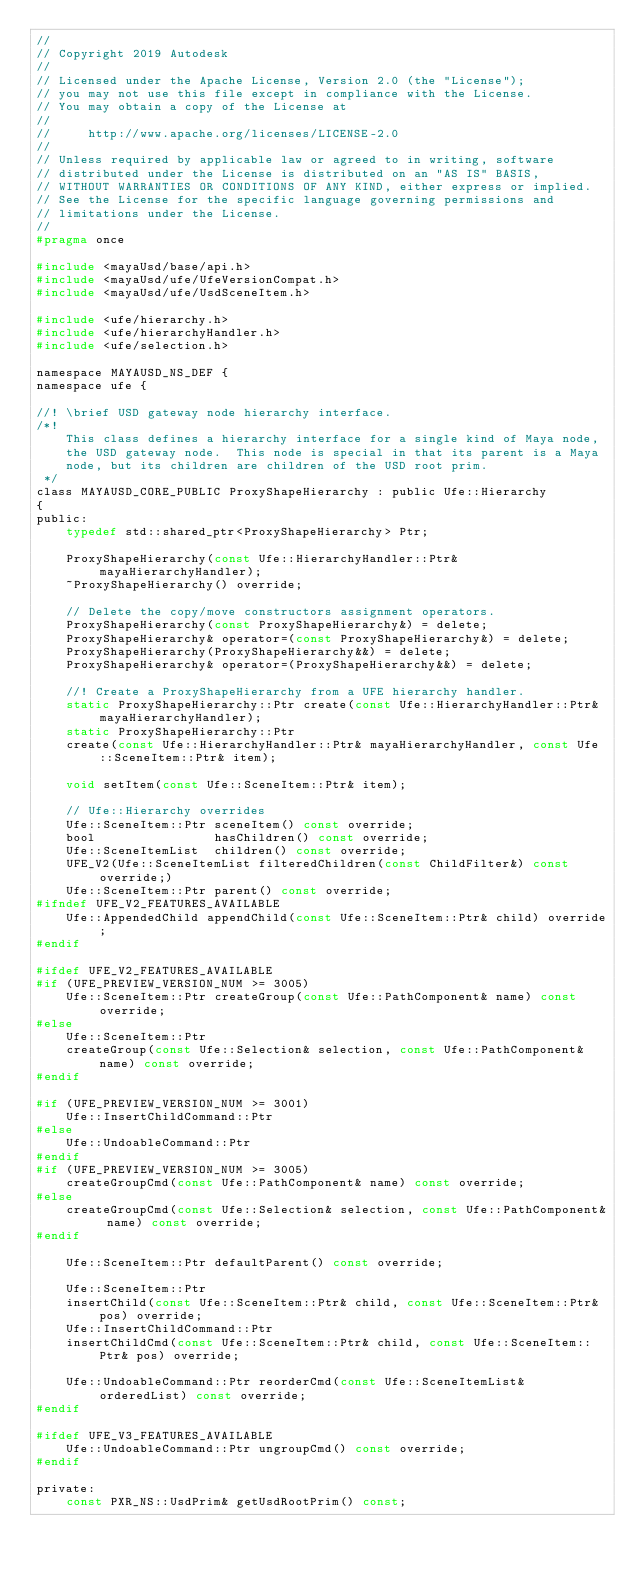<code> <loc_0><loc_0><loc_500><loc_500><_C_>//
// Copyright 2019 Autodesk
//
// Licensed under the Apache License, Version 2.0 (the "License");
// you may not use this file except in compliance with the License.
// You may obtain a copy of the License at
//
//     http://www.apache.org/licenses/LICENSE-2.0
//
// Unless required by applicable law or agreed to in writing, software
// distributed under the License is distributed on an "AS IS" BASIS,
// WITHOUT WARRANTIES OR CONDITIONS OF ANY KIND, either express or implied.
// See the License for the specific language governing permissions and
// limitations under the License.
//
#pragma once

#include <mayaUsd/base/api.h>
#include <mayaUsd/ufe/UfeVersionCompat.h>
#include <mayaUsd/ufe/UsdSceneItem.h>

#include <ufe/hierarchy.h>
#include <ufe/hierarchyHandler.h>
#include <ufe/selection.h>

namespace MAYAUSD_NS_DEF {
namespace ufe {

//! \brief USD gateway node hierarchy interface.
/*!
    This class defines a hierarchy interface for a single kind of Maya node,
    the USD gateway node.  This node is special in that its parent is a Maya
    node, but its children are children of the USD root prim.
 */
class MAYAUSD_CORE_PUBLIC ProxyShapeHierarchy : public Ufe::Hierarchy
{
public:
    typedef std::shared_ptr<ProxyShapeHierarchy> Ptr;

    ProxyShapeHierarchy(const Ufe::HierarchyHandler::Ptr& mayaHierarchyHandler);
    ~ProxyShapeHierarchy() override;

    // Delete the copy/move constructors assignment operators.
    ProxyShapeHierarchy(const ProxyShapeHierarchy&) = delete;
    ProxyShapeHierarchy& operator=(const ProxyShapeHierarchy&) = delete;
    ProxyShapeHierarchy(ProxyShapeHierarchy&&) = delete;
    ProxyShapeHierarchy& operator=(ProxyShapeHierarchy&&) = delete;

    //! Create a ProxyShapeHierarchy from a UFE hierarchy handler.
    static ProxyShapeHierarchy::Ptr create(const Ufe::HierarchyHandler::Ptr& mayaHierarchyHandler);
    static ProxyShapeHierarchy::Ptr
    create(const Ufe::HierarchyHandler::Ptr& mayaHierarchyHandler, const Ufe::SceneItem::Ptr& item);

    void setItem(const Ufe::SceneItem::Ptr& item);

    // Ufe::Hierarchy overrides
    Ufe::SceneItem::Ptr sceneItem() const override;
    bool                hasChildren() const override;
    Ufe::SceneItemList  children() const override;
    UFE_V2(Ufe::SceneItemList filteredChildren(const ChildFilter&) const override;)
    Ufe::SceneItem::Ptr parent() const override;
#ifndef UFE_V2_FEATURES_AVAILABLE
    Ufe::AppendedChild appendChild(const Ufe::SceneItem::Ptr& child) override;
#endif

#ifdef UFE_V2_FEATURES_AVAILABLE
#if (UFE_PREVIEW_VERSION_NUM >= 3005)
    Ufe::SceneItem::Ptr createGroup(const Ufe::PathComponent& name) const override;
#else
    Ufe::SceneItem::Ptr
    createGroup(const Ufe::Selection& selection, const Ufe::PathComponent& name) const override;
#endif

#if (UFE_PREVIEW_VERSION_NUM >= 3001)
    Ufe::InsertChildCommand::Ptr
#else
    Ufe::UndoableCommand::Ptr
#endif
#if (UFE_PREVIEW_VERSION_NUM >= 3005)
    createGroupCmd(const Ufe::PathComponent& name) const override;
#else
    createGroupCmd(const Ufe::Selection& selection, const Ufe::PathComponent& name) const override;
#endif

    Ufe::SceneItem::Ptr defaultParent() const override;

    Ufe::SceneItem::Ptr
    insertChild(const Ufe::SceneItem::Ptr& child, const Ufe::SceneItem::Ptr& pos) override;
    Ufe::InsertChildCommand::Ptr
    insertChildCmd(const Ufe::SceneItem::Ptr& child, const Ufe::SceneItem::Ptr& pos) override;

    Ufe::UndoableCommand::Ptr reorderCmd(const Ufe::SceneItemList& orderedList) const override;
#endif

#ifdef UFE_V3_FEATURES_AVAILABLE
    Ufe::UndoableCommand::Ptr ungroupCmd() const override;
#endif

private:
    const PXR_NS::UsdPrim& getUsdRootPrim() const;</code> 